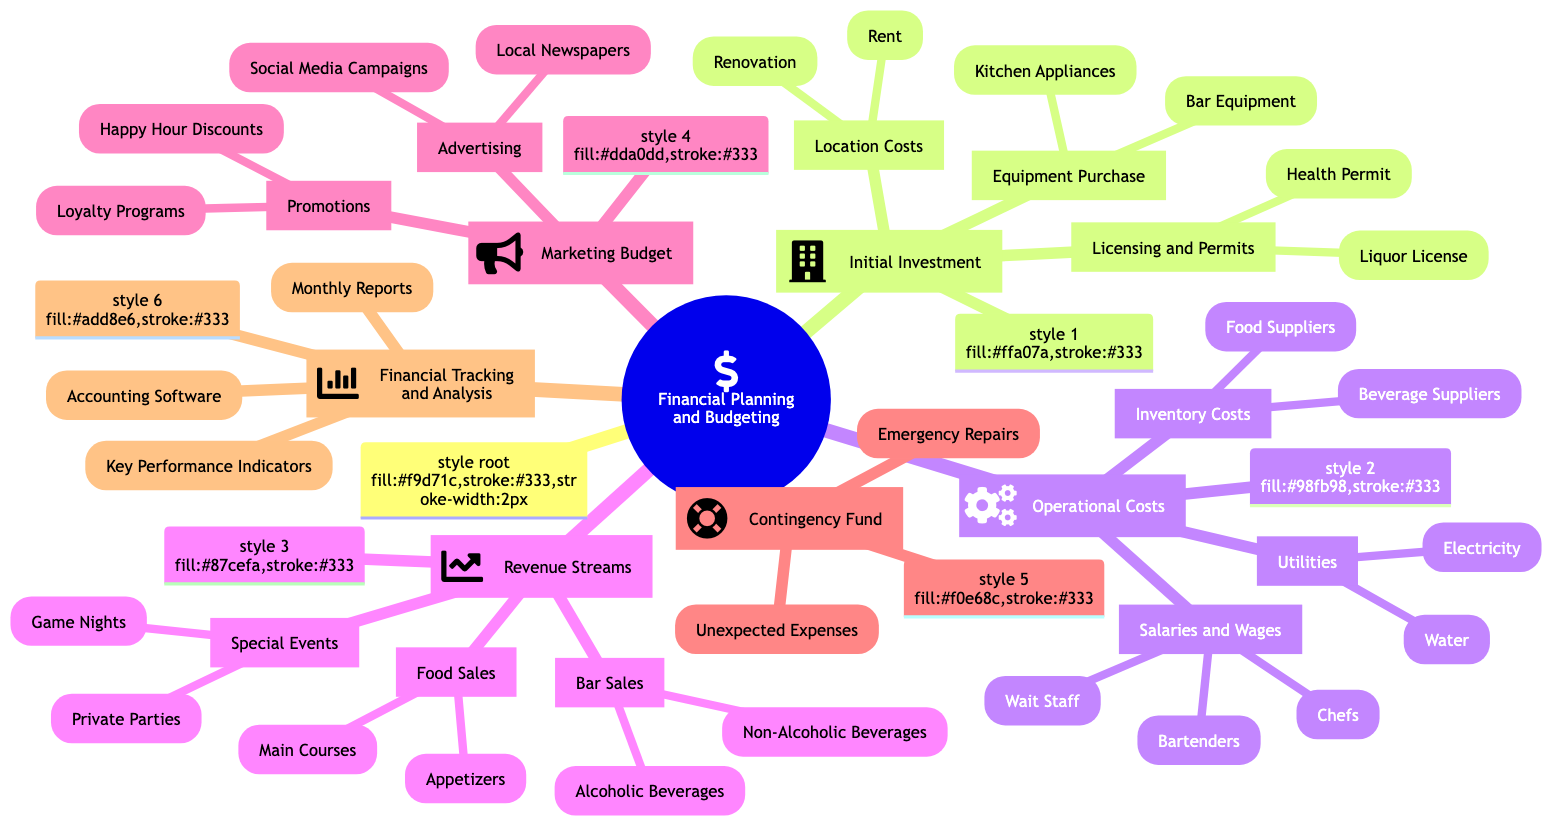What are the main components of the Initial Investment? The Initial Investment comprises three main components: Location Costs, Licensing and Permits, and Equipment Purchase.
Answer: Location Costs, Licensing and Permits, Equipment Purchase How many types of Operational Costs are listed in the diagram? There are three types of Operational Costs listed: Utilities, Salaries and Wages, and Inventory Costs. Counting each of them gives a total of three.
Answer: 3 What does the Marketing Budget include under Promotions? The Marketing Budget includes two specific items under Promotions: Happy Hour Discounts and Loyalty Programs.
Answer: Happy Hour Discounts, Loyalty Programs What is identified as part of the Contingency Fund? The Contingency Fund includes Emergency Repairs and Unexpected Expenses. Combining both items gives the complete answer.
Answer: Emergency Repairs, Unexpected Expenses Which software is used for Financial Tracking and Analysis? The diagram specifies QuickBooks as the Accounting Software used for Financial Tracking and Analysis.
Answer: QuickBooks How can you categorize the Revenue Streams? The Revenue Streams are categorized into Bar Sales, Food Sales, and Special Events. This organization shows the different sources of income.
Answer: Bar Sales, Food Sales, Special Events What type of advertising is listed for the Marketing Budget? The diagram mentions Social Media Campaigns and Local Newspapers as the types of advertising for the Marketing Budget.
Answer: Social Media Campaigns, Local Newspapers Which utility provider is listed for Electricity costs? Alliant Energy is identified as the utility provider for Electricity costs in the Operational Costs section.
Answer: Alliant Energy What are the Key Performance Indicators mentioned in the diagram? The Key Performance Indicators include Net Profit Margin and Customer Acquisition Cost, both crucial for financial analysis.
Answer: Net Profit Margin, Customer Acquisition Cost 